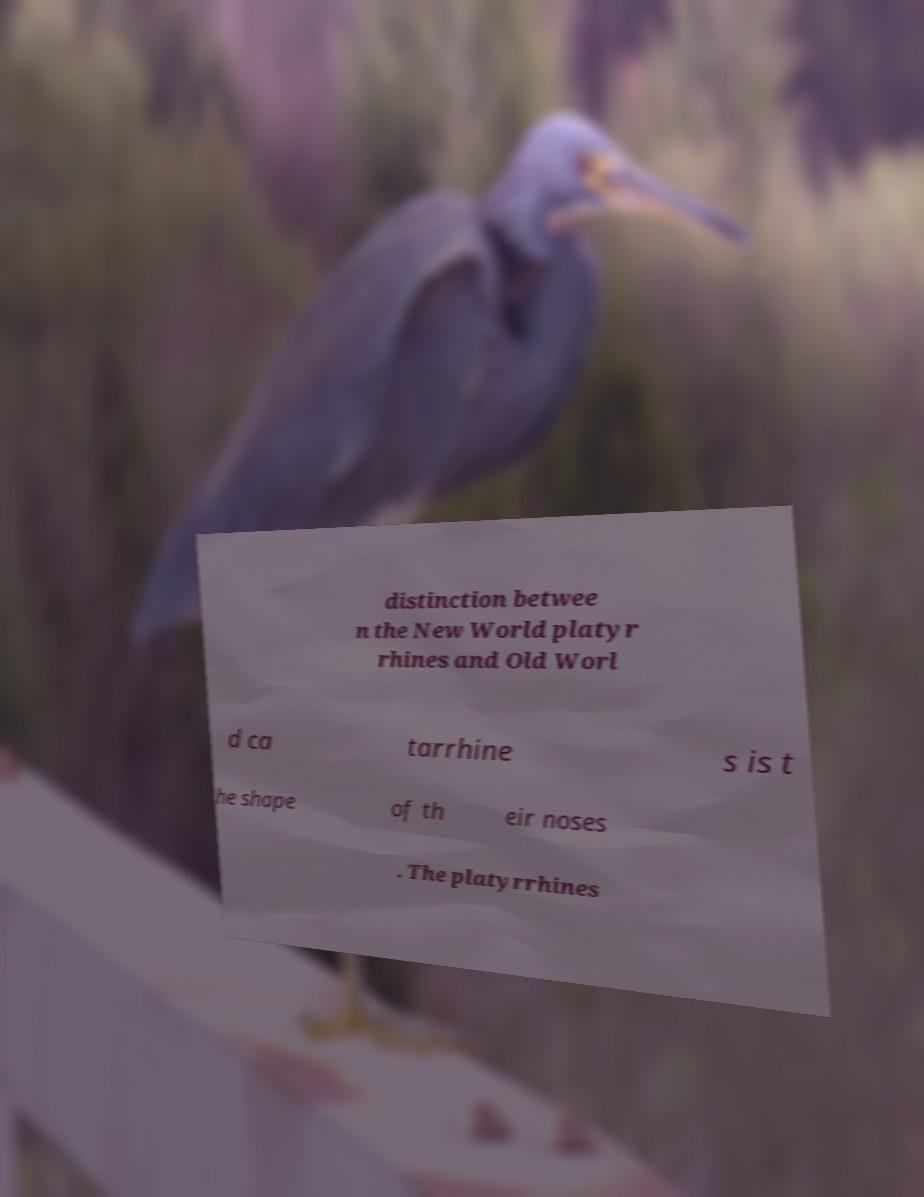I need the written content from this picture converted into text. Can you do that? distinction betwee n the New World platyr rhines and Old Worl d ca tarrhine s is t he shape of th eir noses . The platyrrhines 